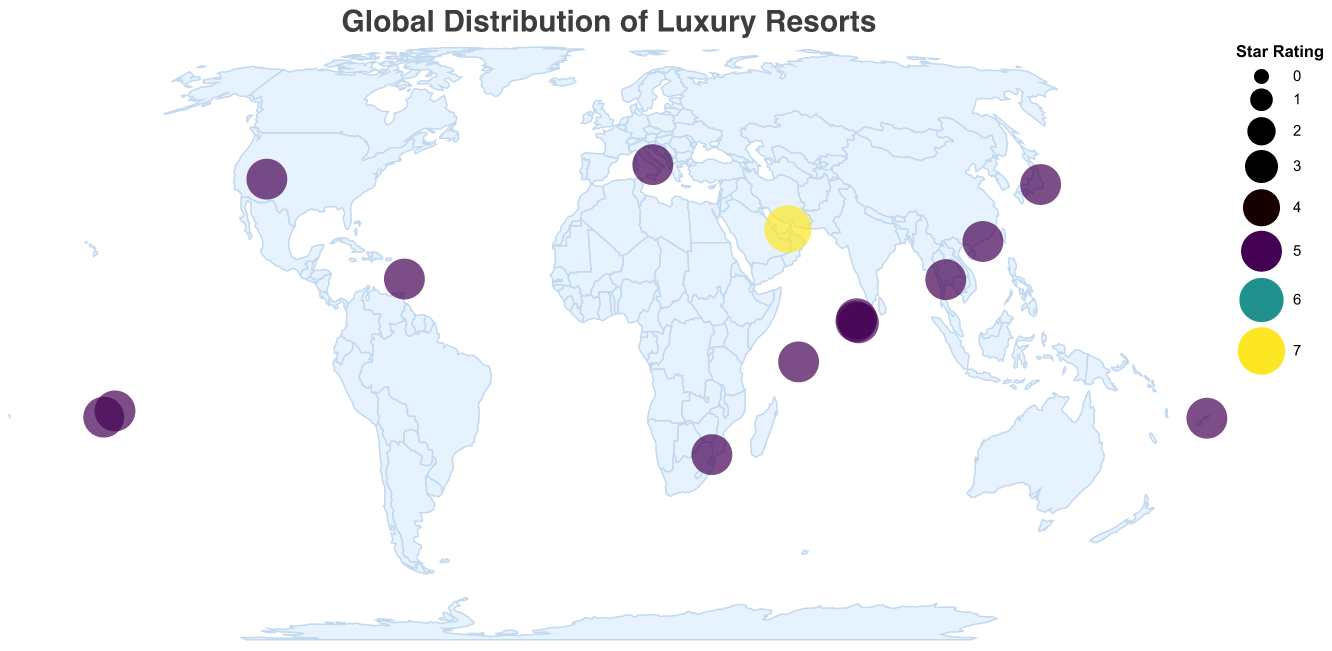What is the title of the figure? The title is displayed at the top of the figure in a larger font size and reads "Global Distribution of Luxury Resorts".
Answer: Global Distribution of Luxury Resorts Which resort has the highest star rating? Observing the plot, the largest circle signifies the highest star rating. The tooltip reveals that the Burj Al Arab Jumeirah in the United Arab Emirates has a star rating of 7.
Answer: Burj Al Arab Jumeirah How many resorts are plotted on the map? By counting each circle representing a resort on the map, we determine there are 15 resorts plotted.
Answer: 15 Which countries have more than one luxury resort listed in the plot? Checking the tooltip for resorts with the same country label, French Polynesia and Maldives each have more than one resort.
Answer: French Polynesia, Maldives What is the southernmost resort on the map? By identifying the resort with the smallest latitude value, Singita Lebombo Lodge in South Africa is the southernmost.
Answer: Singita Lebombo Lodge What is the average star rating of the luxury resorts in the Maldives? The plotted resorts in the Maldives are Soneva Fushi, The Ritz-Carlton Maldives, and One&Only Reethi Rah, each with a star rating of 5. (5 + 5 + 5) / 3 = 5.
Answer: 5 Which luxury resort is closest to the equator? The resort closest to a latitude of 0 is The Ritz-Carlton Maldives with a latitude of 4.2254.
Answer: The Ritz-Carlton Maldives Compare the star rating of the Aman Tokyo resort and the Belmond Hotel Caruso. Which one has a higher rating? Both resorts have the same star rating, as shown by similar-sized circles and tooltip information of 5 stars each.
Answer: Neither, both have a 5-star rating Which region in the world appears to have a higher density of luxury resorts? Observing the clusters of circles, the region around the Indian Ocean, including the Maldives, French Polynesia, and nearby areas, has a higher density of luxury resorts.
Answer: Indian Ocean region 